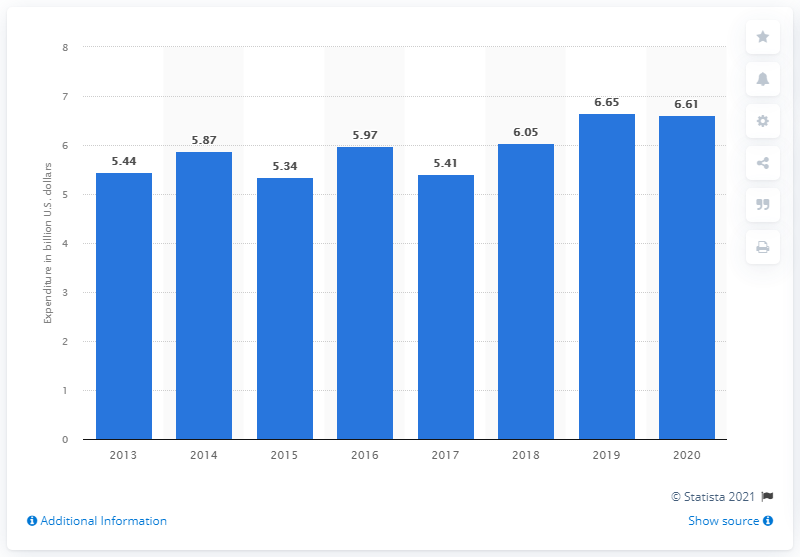List a handful of essential elements in this visual. The Mexican government spent 6.61 million dollars in the military a year earlier. The Mexican government spent 6.61 billion dollars on the military in the year 2020. 